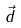Convert formula to latex. <formula><loc_0><loc_0><loc_500><loc_500>\vec { d }</formula> 